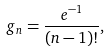<formula> <loc_0><loc_0><loc_500><loc_500>g _ { n } = \frac { e ^ { - 1 } } { ( n - 1 ) ! } ,</formula> 